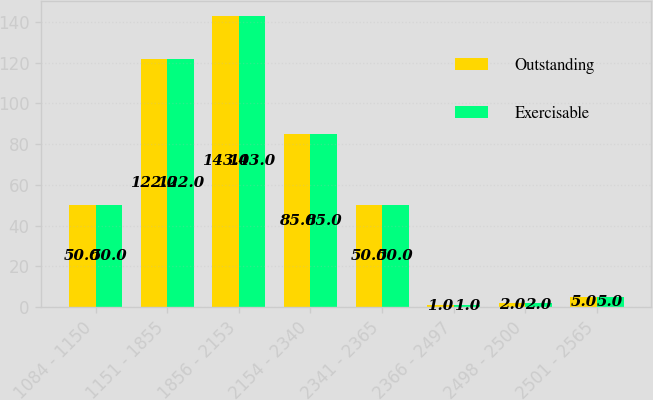Convert chart to OTSL. <chart><loc_0><loc_0><loc_500><loc_500><stacked_bar_chart><ecel><fcel>1084 - 1150<fcel>1151 - 1855<fcel>1856 - 2153<fcel>2154 - 2340<fcel>2341 - 2365<fcel>2366 - 2497<fcel>2498 - 2500<fcel>2501 - 2565<nl><fcel>Outstanding<fcel>50<fcel>122<fcel>143<fcel>85<fcel>50<fcel>1<fcel>2<fcel>5<nl><fcel>Exercisable<fcel>50<fcel>122<fcel>143<fcel>85<fcel>50<fcel>1<fcel>2<fcel>5<nl></chart> 